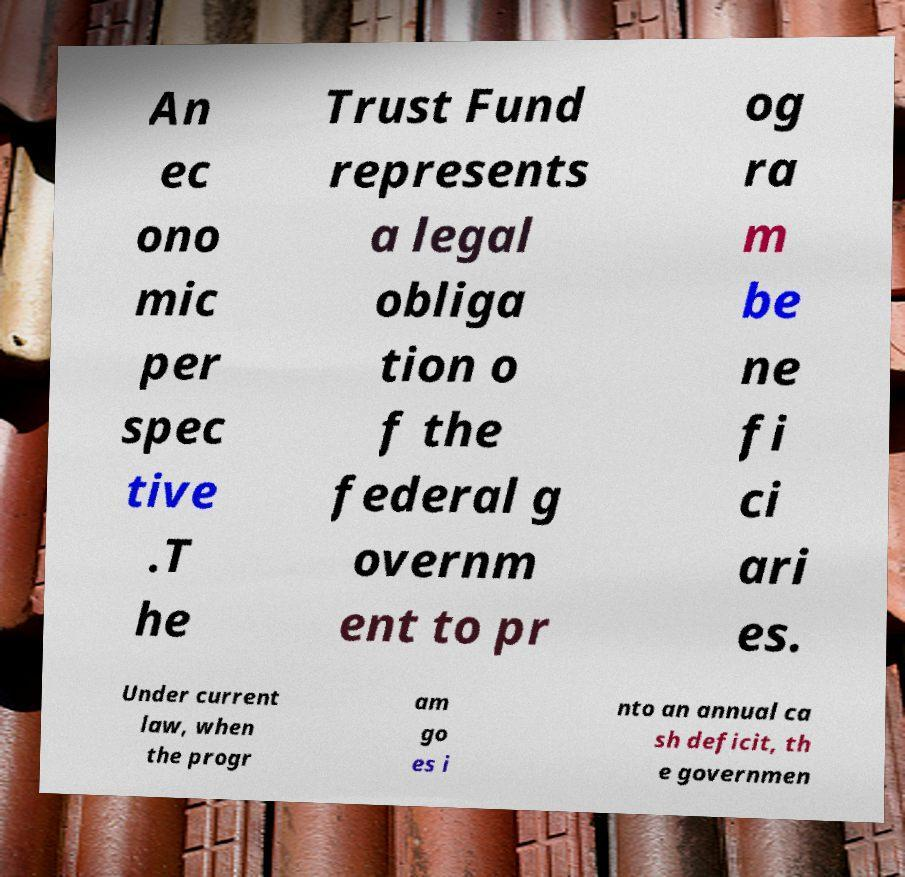For documentation purposes, I need the text within this image transcribed. Could you provide that? An ec ono mic per spec tive .T he Trust Fund represents a legal obliga tion o f the federal g overnm ent to pr og ra m be ne fi ci ari es. Under current law, when the progr am go es i nto an annual ca sh deficit, th e governmen 